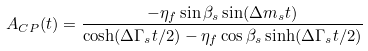Convert formula to latex. <formula><loc_0><loc_0><loc_500><loc_500>A _ { C P } ( t ) = \frac { - \eta _ { f } \sin \beta _ { s } \sin ( \Delta m _ { s } t ) } { \cosh ( \Delta \Gamma _ { s } t / 2 ) - \eta _ { f } \cos \beta _ { s } \sinh ( \Delta \Gamma _ { s } t / 2 ) }</formula> 